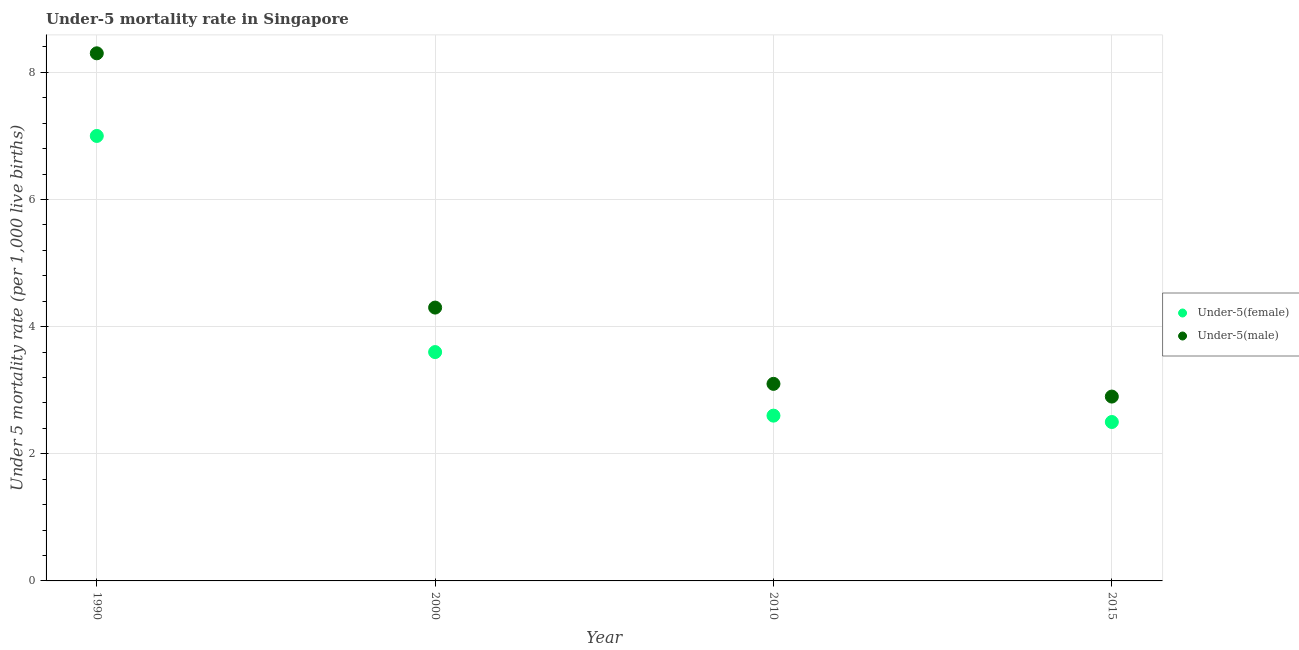Is the number of dotlines equal to the number of legend labels?
Give a very brief answer. Yes. Across all years, what is the minimum under-5 female mortality rate?
Your answer should be very brief. 2.5. In which year was the under-5 female mortality rate minimum?
Provide a succinct answer. 2015. What is the total under-5 female mortality rate in the graph?
Ensure brevity in your answer.  15.7. What is the difference between the under-5 female mortality rate in 1990 and the under-5 male mortality rate in 2015?
Your response must be concise. 4.1. What is the average under-5 female mortality rate per year?
Your answer should be compact. 3.92. In the year 2000, what is the difference between the under-5 female mortality rate and under-5 male mortality rate?
Your answer should be compact. -0.7. What is the ratio of the under-5 male mortality rate in 1990 to that in 2015?
Ensure brevity in your answer.  2.86. Is the difference between the under-5 female mortality rate in 2000 and 2015 greater than the difference between the under-5 male mortality rate in 2000 and 2015?
Ensure brevity in your answer.  No. What is the difference between the highest and the second highest under-5 female mortality rate?
Keep it short and to the point. 3.4. What is the difference between the highest and the lowest under-5 female mortality rate?
Keep it short and to the point. 4.5. In how many years, is the under-5 male mortality rate greater than the average under-5 male mortality rate taken over all years?
Your response must be concise. 1. Does the under-5 female mortality rate monotonically increase over the years?
Give a very brief answer. No. Is the under-5 female mortality rate strictly greater than the under-5 male mortality rate over the years?
Give a very brief answer. No. How many dotlines are there?
Offer a very short reply. 2. What is the difference between two consecutive major ticks on the Y-axis?
Make the answer very short. 2. Does the graph contain any zero values?
Your answer should be compact. No. Does the graph contain grids?
Your answer should be compact. Yes. Where does the legend appear in the graph?
Make the answer very short. Center right. How are the legend labels stacked?
Your answer should be very brief. Vertical. What is the title of the graph?
Make the answer very short. Under-5 mortality rate in Singapore. Does "Merchandise imports" appear as one of the legend labels in the graph?
Ensure brevity in your answer.  No. What is the label or title of the X-axis?
Provide a short and direct response. Year. What is the label or title of the Y-axis?
Make the answer very short. Under 5 mortality rate (per 1,0 live births). What is the Under 5 mortality rate (per 1,000 live births) of Under-5(female) in 2010?
Your response must be concise. 2.6. What is the Under 5 mortality rate (per 1,000 live births) of Under-5(male) in 2010?
Keep it short and to the point. 3.1. What is the Under 5 mortality rate (per 1,000 live births) in Under-5(female) in 2015?
Offer a very short reply. 2.5. Across all years, what is the maximum Under 5 mortality rate (per 1,000 live births) in Under-5(female)?
Your response must be concise. 7. Across all years, what is the minimum Under 5 mortality rate (per 1,000 live births) in Under-5(female)?
Offer a very short reply. 2.5. What is the total Under 5 mortality rate (per 1,000 live births) of Under-5(male) in the graph?
Offer a very short reply. 18.6. What is the difference between the Under 5 mortality rate (per 1,000 live births) of Under-5(female) in 1990 and that in 2000?
Offer a very short reply. 3.4. What is the difference between the Under 5 mortality rate (per 1,000 live births) of Under-5(male) in 1990 and that in 2000?
Offer a very short reply. 4. What is the difference between the Under 5 mortality rate (per 1,000 live births) in Under-5(male) in 1990 and that in 2015?
Your answer should be very brief. 5.4. What is the difference between the Under 5 mortality rate (per 1,000 live births) of Under-5(female) in 2000 and that in 2010?
Ensure brevity in your answer.  1. What is the difference between the Under 5 mortality rate (per 1,000 live births) of Under-5(male) in 2000 and that in 2010?
Ensure brevity in your answer.  1.2. What is the difference between the Under 5 mortality rate (per 1,000 live births) of Under-5(female) in 2000 and that in 2015?
Ensure brevity in your answer.  1.1. What is the difference between the Under 5 mortality rate (per 1,000 live births) of Under-5(male) in 2010 and that in 2015?
Your response must be concise. 0.2. What is the difference between the Under 5 mortality rate (per 1,000 live births) of Under-5(female) in 1990 and the Under 5 mortality rate (per 1,000 live births) of Under-5(male) in 2000?
Ensure brevity in your answer.  2.7. What is the difference between the Under 5 mortality rate (per 1,000 live births) in Under-5(female) in 1990 and the Under 5 mortality rate (per 1,000 live births) in Under-5(male) in 2015?
Offer a very short reply. 4.1. What is the average Under 5 mortality rate (per 1,000 live births) in Under-5(female) per year?
Provide a succinct answer. 3.92. What is the average Under 5 mortality rate (per 1,000 live births) of Under-5(male) per year?
Ensure brevity in your answer.  4.65. In the year 1990, what is the difference between the Under 5 mortality rate (per 1,000 live births) in Under-5(female) and Under 5 mortality rate (per 1,000 live births) in Under-5(male)?
Your response must be concise. -1.3. In the year 2000, what is the difference between the Under 5 mortality rate (per 1,000 live births) in Under-5(female) and Under 5 mortality rate (per 1,000 live births) in Under-5(male)?
Your response must be concise. -0.7. In the year 2010, what is the difference between the Under 5 mortality rate (per 1,000 live births) in Under-5(female) and Under 5 mortality rate (per 1,000 live births) in Under-5(male)?
Your response must be concise. -0.5. What is the ratio of the Under 5 mortality rate (per 1,000 live births) of Under-5(female) in 1990 to that in 2000?
Provide a short and direct response. 1.94. What is the ratio of the Under 5 mortality rate (per 1,000 live births) of Under-5(male) in 1990 to that in 2000?
Offer a terse response. 1.93. What is the ratio of the Under 5 mortality rate (per 1,000 live births) in Under-5(female) in 1990 to that in 2010?
Keep it short and to the point. 2.69. What is the ratio of the Under 5 mortality rate (per 1,000 live births) in Under-5(male) in 1990 to that in 2010?
Your response must be concise. 2.68. What is the ratio of the Under 5 mortality rate (per 1,000 live births) in Under-5(female) in 1990 to that in 2015?
Ensure brevity in your answer.  2.8. What is the ratio of the Under 5 mortality rate (per 1,000 live births) of Under-5(male) in 1990 to that in 2015?
Give a very brief answer. 2.86. What is the ratio of the Under 5 mortality rate (per 1,000 live births) of Under-5(female) in 2000 to that in 2010?
Offer a very short reply. 1.38. What is the ratio of the Under 5 mortality rate (per 1,000 live births) of Under-5(male) in 2000 to that in 2010?
Ensure brevity in your answer.  1.39. What is the ratio of the Under 5 mortality rate (per 1,000 live births) of Under-5(female) in 2000 to that in 2015?
Offer a very short reply. 1.44. What is the ratio of the Under 5 mortality rate (per 1,000 live births) in Under-5(male) in 2000 to that in 2015?
Give a very brief answer. 1.48. What is the ratio of the Under 5 mortality rate (per 1,000 live births) of Under-5(female) in 2010 to that in 2015?
Your answer should be very brief. 1.04. What is the ratio of the Under 5 mortality rate (per 1,000 live births) of Under-5(male) in 2010 to that in 2015?
Give a very brief answer. 1.07. What is the difference between the highest and the second highest Under 5 mortality rate (per 1,000 live births) in Under-5(female)?
Provide a succinct answer. 3.4. What is the difference between the highest and the second highest Under 5 mortality rate (per 1,000 live births) in Under-5(male)?
Provide a succinct answer. 4. 